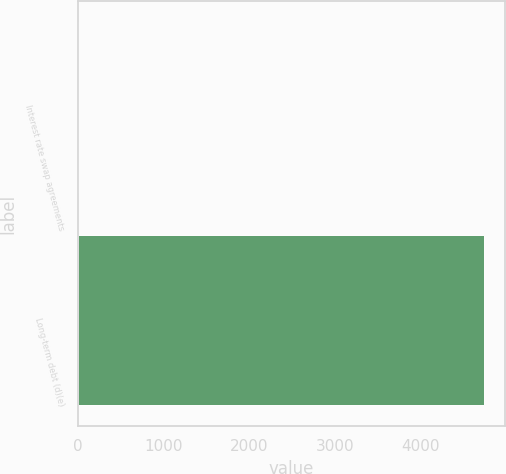Convert chart to OTSL. <chart><loc_0><loc_0><loc_500><loc_500><bar_chart><fcel>Interest rate swap agreements<fcel>Long-term debt (d)(e)<nl><fcel>4<fcel>4740<nl></chart> 